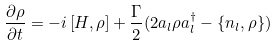<formula> <loc_0><loc_0><loc_500><loc_500>\frac { \partial \rho } { \partial t } = - i \left [ H , \rho \right ] + \frac { \Gamma } { 2 } ( 2 a _ { l } \rho a _ { l } ^ { \dagger } - \{ n _ { l } , \rho \} )</formula> 